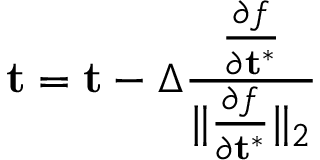Convert formula to latex. <formula><loc_0><loc_0><loc_500><loc_500>t = t - \Delta \frac { \frac { \partial f } { \partial t ^ { * } } } { \| \frac { \partial f } { \partial t ^ { * } } \| _ { 2 } }</formula> 